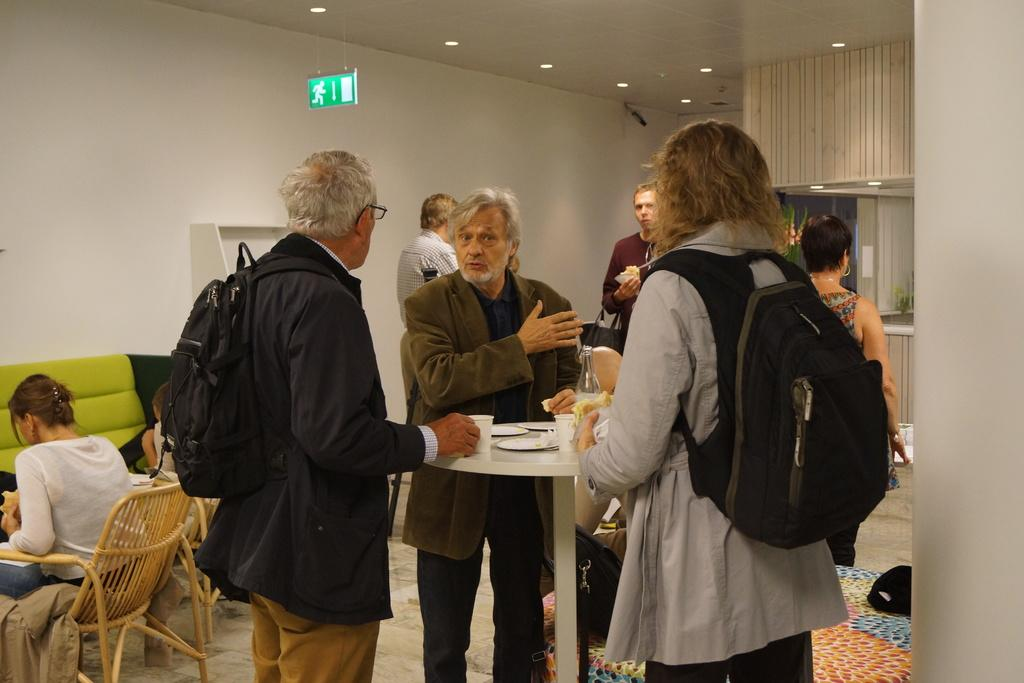What is the color of the wall in the image? There is a white color wall in the image. What can be seen in terms of furniture in the image? There are chairs and a sofa in the image. Can you describe the people in the image? There are people standing in the image. Where is the man located in the image? The man is standing on the right side of the image. What is the man wearing in the image? The man is wearing a bag in the image. What is the name of the man's mom in the image? There is no information about the man's mom in the image, so we cannot determine her name. 